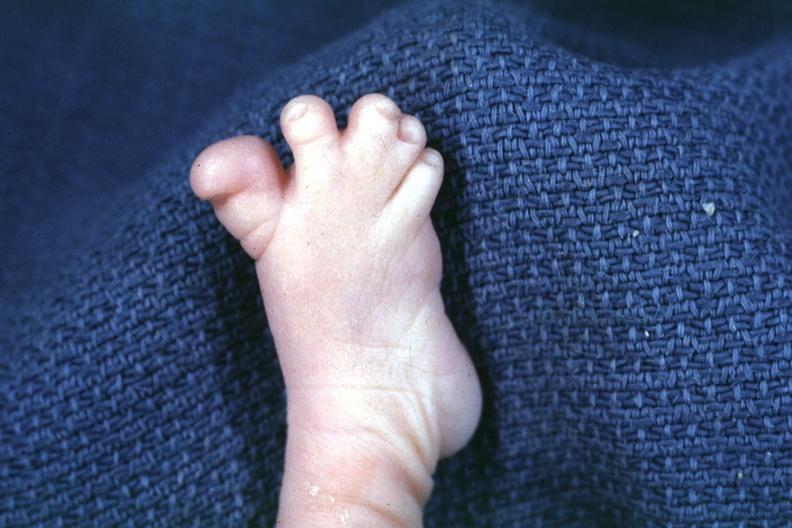what are present?
Answer the question using a single word or phrase. Extremities 